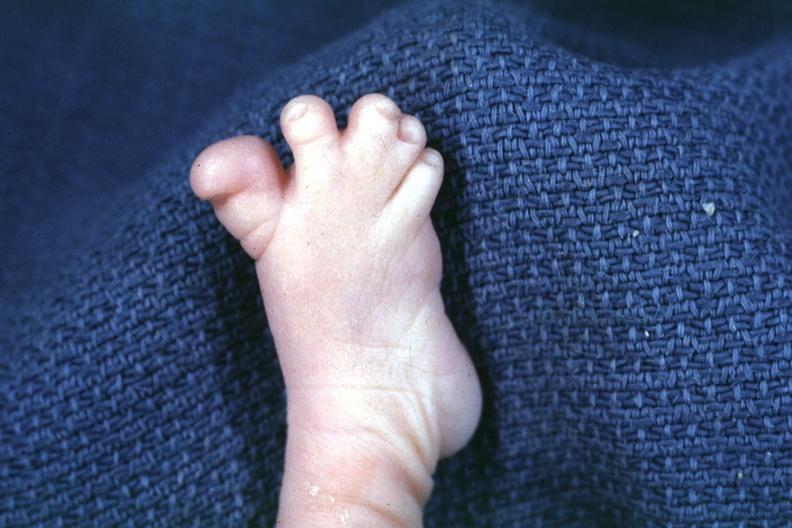what are present?
Answer the question using a single word or phrase. Extremities 